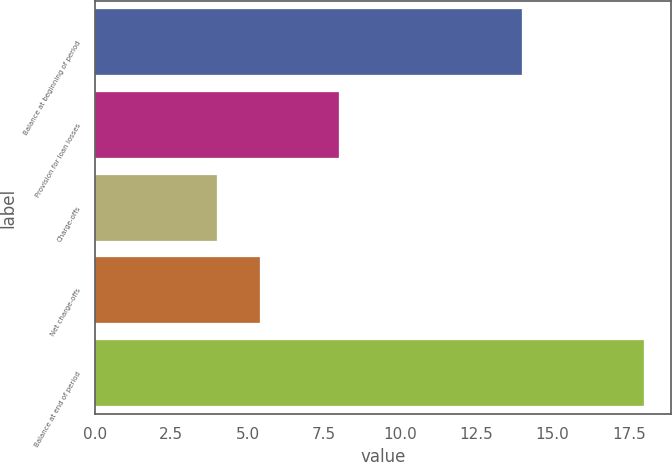<chart> <loc_0><loc_0><loc_500><loc_500><bar_chart><fcel>Balance at beginning of period<fcel>Provision for loan losses<fcel>Charge-offs<fcel>Net charge-offs<fcel>Balance at end of period<nl><fcel>14<fcel>8<fcel>4<fcel>5.4<fcel>18<nl></chart> 